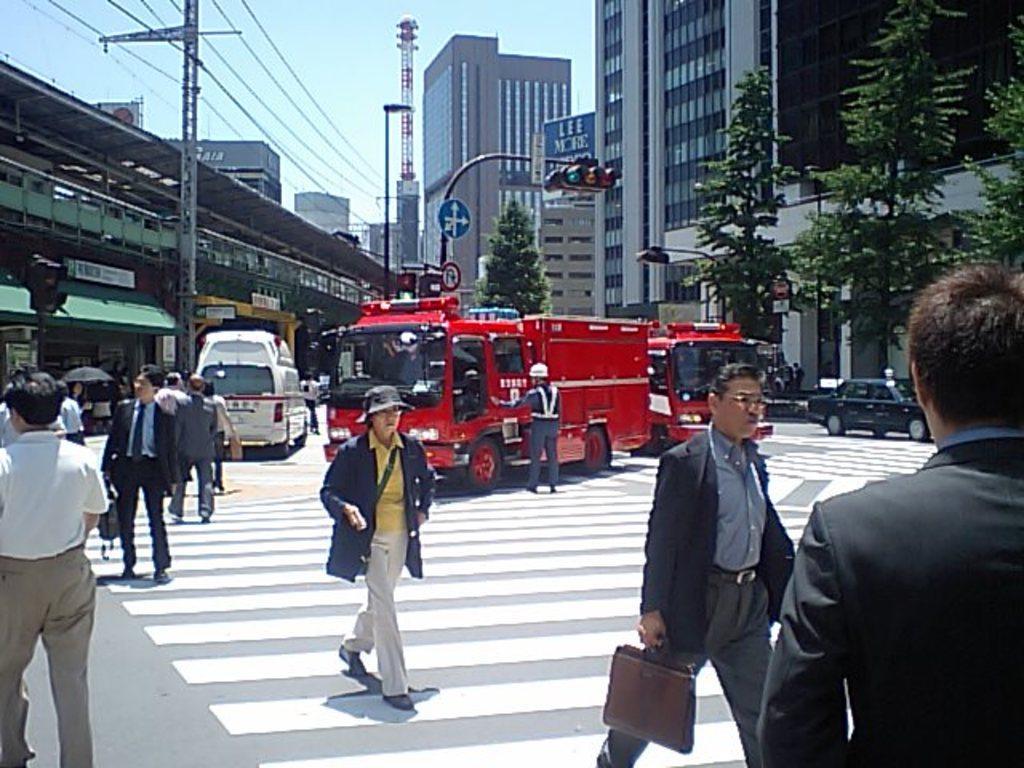Describe this image in one or two sentences. In this image we can see there are buildings, people, vehicles, trees, traffic lights and poles. In the background we can see the sky. 